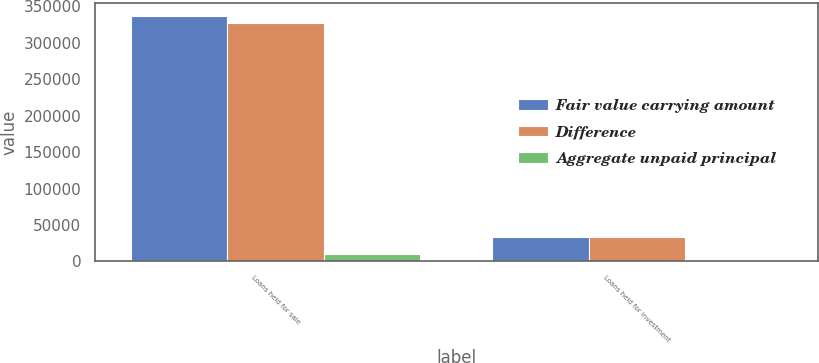Convert chart. <chart><loc_0><loc_0><loc_500><loc_500><stacked_bar_chart><ecel><fcel>Loans held for sale<fcel>Loans held for investment<nl><fcel>Fair value carrying amount<fcel>337577<fcel>32889<nl><fcel>Difference<fcel>326802<fcel>33637<nl><fcel>Aggregate unpaid principal<fcel>10775<fcel>748<nl></chart> 